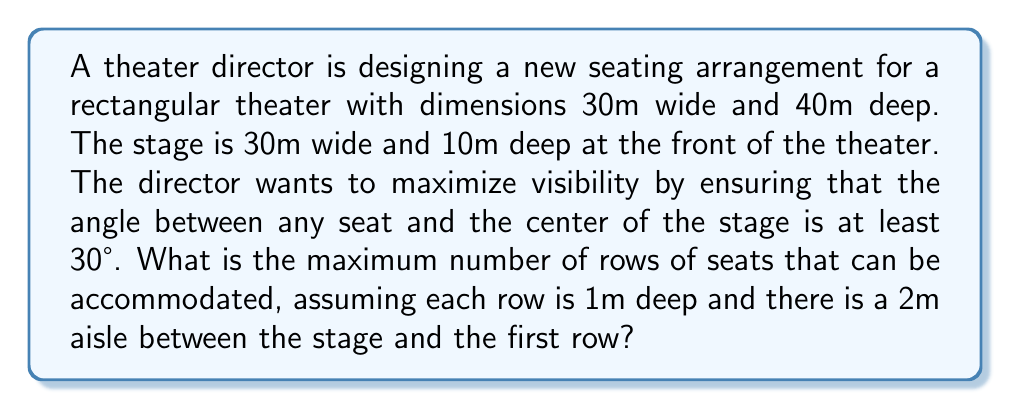Teach me how to tackle this problem. Let's approach this step-by-step:

1) First, we need to calculate the distance from the stage to the back of the theater:
   40m (total depth) - 10m (stage depth) = 30m

2) We also need to account for the 2m aisle, so the actual seating area depth is:
   30m - 2m = 28m

3) Now, let's consider the angle requirement. We can use trigonometry to determine the maximum distance a seat can be from the stage while maintaining a 30° angle to the center.

4) If we draw a right triangle from the center of the stage to the furthest seat, we have:
   - The adjacent side is half the stage width: 15m
   - The angle is 30°
   - We need to find the hypotenuse

5) Using the tangent function:
   $$\tan(30°) = \frac{15}{x}$$
   Where $x$ is the maximum distance from the stage to the last row.

6) Solving for $x$:
   $$x = \frac{15}{\tan(30°)} \approx 25.98m$$

7) This means the maximum distance for seating is about 25.98m from the stage.

8) Remember, we have a 2m aisle, so the actual seating area can be:
   25.98m - 2m = 23.98m deep

9) Since each row is 1m deep, we can fit:
   $$\lfloor 23.98 \rfloor = 23$$ rows

Therefore, the maximum number of rows that can be accommodated is 23.
Answer: 23 rows 